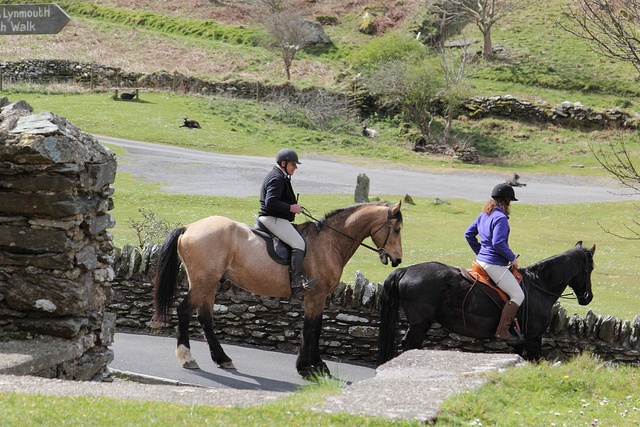Describe the objects in this image and their specific colors. I can see horse in olive, black, gray, and maroon tones, horse in olive, black, gray, darkgray, and tan tones, people in olive, black, darkgray, violet, and navy tones, and people in olive, black, darkgray, gray, and lightgray tones in this image. 